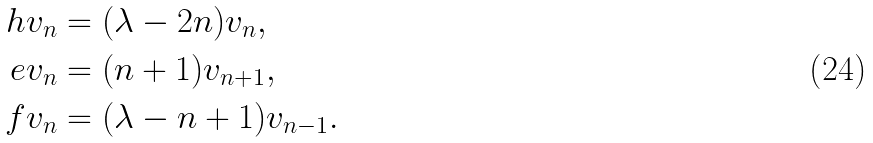<formula> <loc_0><loc_0><loc_500><loc_500>h v _ { n } & = ( \lambda - 2 n ) v _ { n } , \\ e v _ { n } & = ( n + 1 ) v _ { n + 1 } , \\ f v _ { n } & = ( \lambda - n + 1 ) v _ { n - 1 } .</formula> 